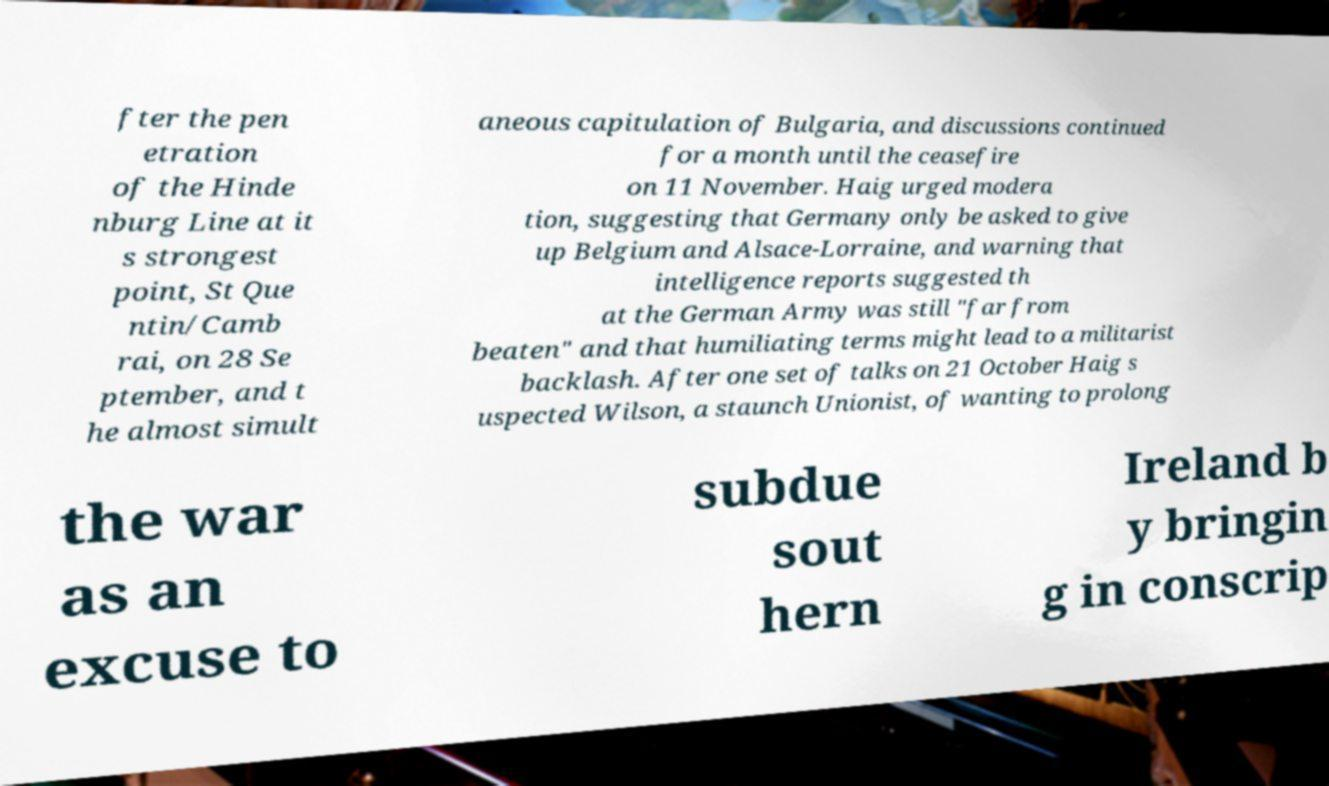Could you extract and type out the text from this image? fter the pen etration of the Hinde nburg Line at it s strongest point, St Que ntin/Camb rai, on 28 Se ptember, and t he almost simult aneous capitulation of Bulgaria, and discussions continued for a month until the ceasefire on 11 November. Haig urged modera tion, suggesting that Germany only be asked to give up Belgium and Alsace-Lorraine, and warning that intelligence reports suggested th at the German Army was still "far from beaten" and that humiliating terms might lead to a militarist backlash. After one set of talks on 21 October Haig s uspected Wilson, a staunch Unionist, of wanting to prolong the war as an excuse to subdue sout hern Ireland b y bringin g in conscrip 